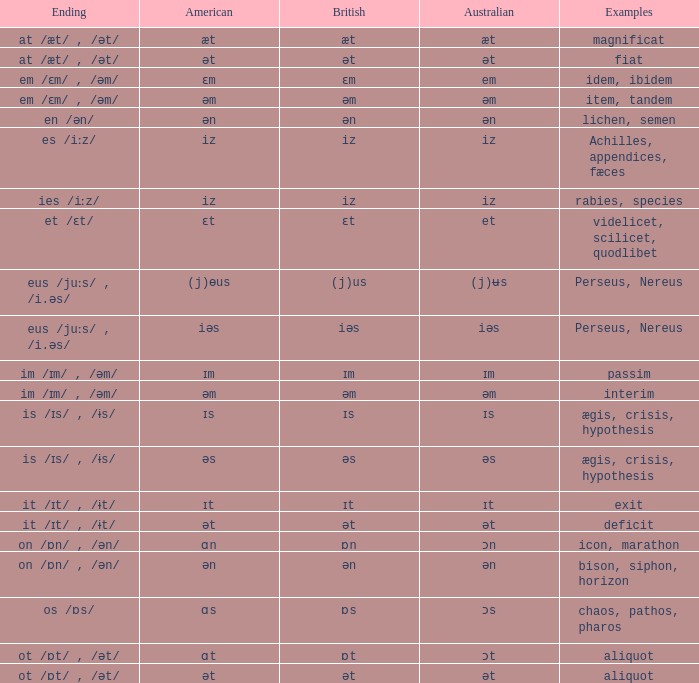Which american possesses british of ɛm? Ɛm. 